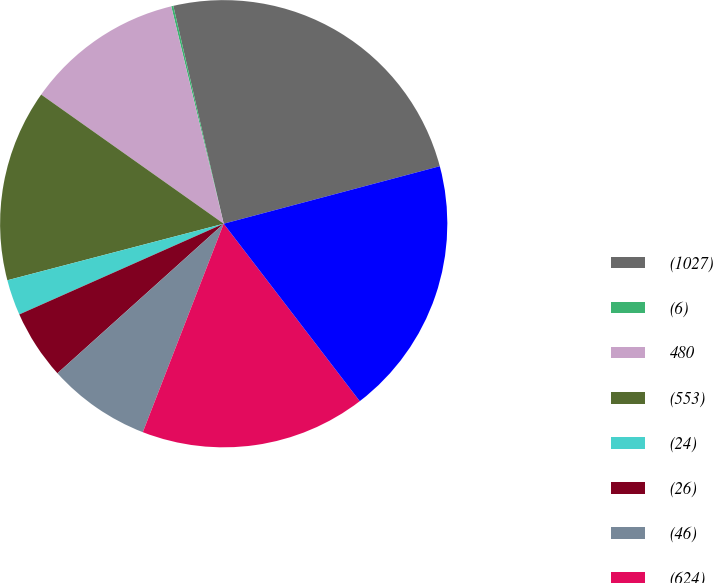<chart> <loc_0><loc_0><loc_500><loc_500><pie_chart><fcel>(1027)<fcel>(6)<fcel>480<fcel>(553)<fcel>(24)<fcel>(26)<fcel>(46)<fcel>(624)<fcel>(684)<nl><fcel>24.48%<fcel>0.15%<fcel>11.43%<fcel>13.87%<fcel>2.58%<fcel>5.01%<fcel>7.45%<fcel>16.3%<fcel>18.73%<nl></chart> 